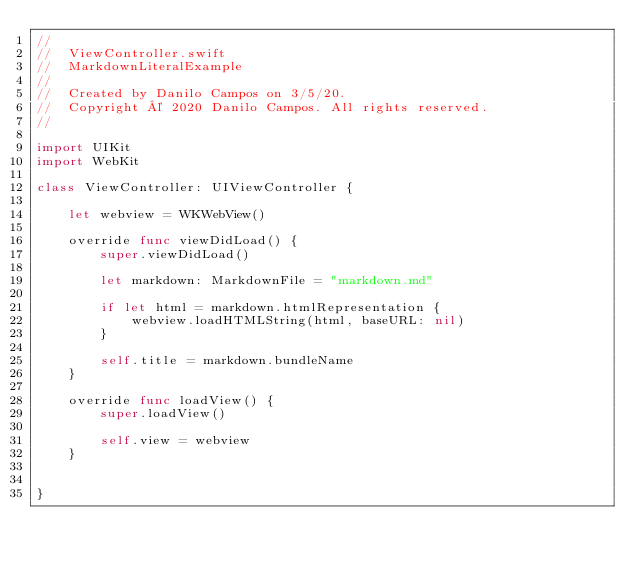<code> <loc_0><loc_0><loc_500><loc_500><_Swift_>//
//  ViewController.swift
//  MarkdownLiteralExample
//
//  Created by Danilo Campos on 3/5/20.
//  Copyright © 2020 Danilo Campos. All rights reserved.
//

import UIKit
import WebKit

class ViewController: UIViewController {
    
    let webview = WKWebView()

    override func viewDidLoad() {
        super.viewDidLoad()

        let markdown: MarkdownFile = "markdown.md"

        if let html = markdown.htmlRepresentation {
            webview.loadHTMLString(html, baseURL: nil)
        }

        self.title = markdown.bundleName
    }
    
    override func loadView() {
        super.loadView()
        
        self.view = webview
    }


}

</code> 